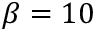<formula> <loc_0><loc_0><loc_500><loc_500>\beta = 1 0</formula> 